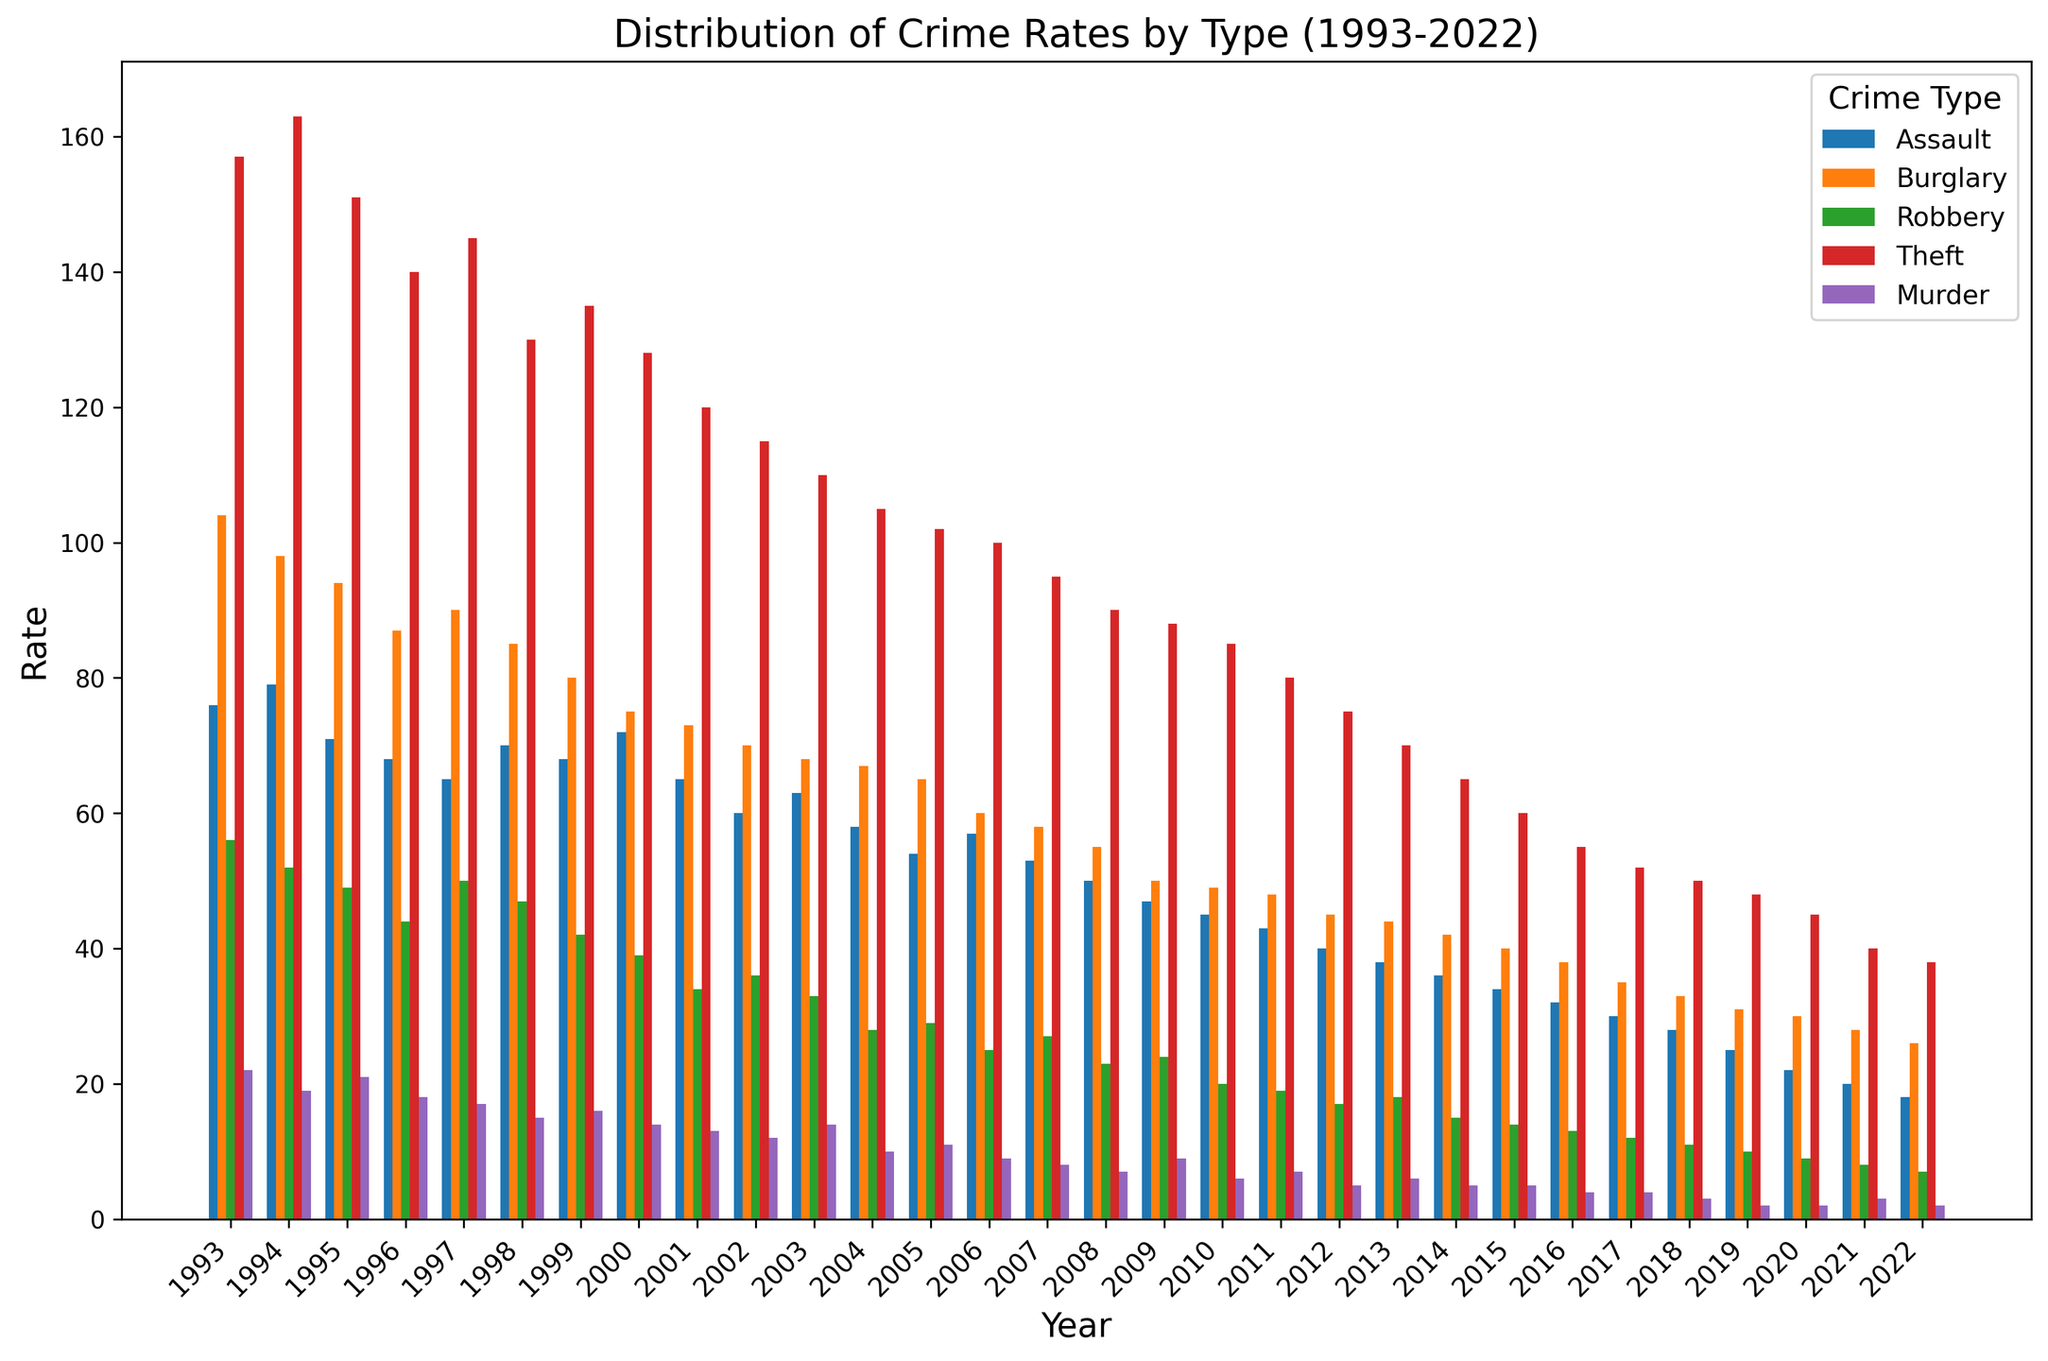What type of crime had the highest rate in 1993? To answer this, look at the bars representing different crime types for the year 1993 and identify the highest one. Theft had the highest bar with a rate of 157.
Answer: Theft Which crime type saw the most significant decrease in rates from 1993 to 2022? By examining the bars in 1993 and comparing them to 2022, identify the type with the largest drop in height. Theft decreased from 157 in 1993 to 38 in 2022, showing the most significant drop.
Answer: Theft How did the rate of Assault in 2000 compare to the rate of Robbery in the same year? Locate the bars for Assault and Robbery for the year 2000. The Assault rate is 72, and the Robbery rate is 39, meaning Assault's rate is higher.
Answer: Assault's rate is higher What is the average rate of Murder across all years shown? Sum the Murder rates across all years and divide by the number of years (30). The sum is 373, so the average is 373 / 30 = 12.43.
Answer: 12.43 Between 2005 and 2010, which year had the lowest rate for Burglary? Compare the heights of the Burglary bars from 2005 to 2010. The lowest bar, indicating the lowest rate, appears in 2010 with a rate of 49.
Answer: 2010 Which crime showed a consistent decrease in rates over the years? Visually inspect the trend of each crime type across the years. The Murder crime rates show a consistent downward trend from 1993 to 2022.
Answer: Murder What were the total rates of Theft and Burglary combined in 1997? Add the Theft and Burglary rates for 1997. Theft is 145, and Burglary is 90, thus the combined rate is 145 + 90 = 235.
Answer: 235 Was there any year where the rate of Robbery exceeded the rate of Assault? Compare the heights of the Robbery and Assault bars for each year. There is no year where the Robbery rate exceeds the Assault rate.
Answer: No Which crime had the lowest rate in 2020? Look at the bars for 2020 and identify the lowest one. Murder had the lowest rate with 2.
Answer: Murder What is the difference in rates for Thefts between 1998 and 2018? Subtract the Theft rate in 2018 from the Theft rate in 1998. 130 - 50 = 80.
Answer: 80 